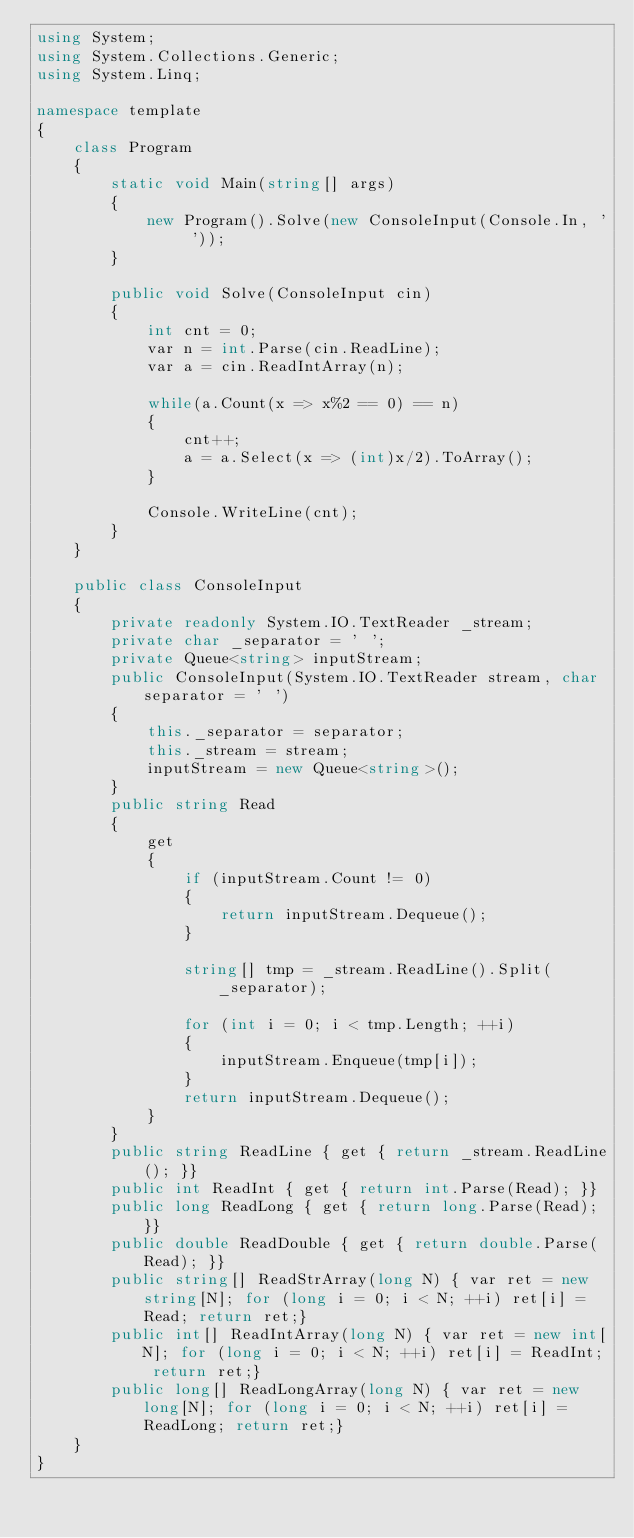<code> <loc_0><loc_0><loc_500><loc_500><_C#_>using System;
using System.Collections.Generic;
using System.Linq;

namespace template
{
    class Program
    {
        static void Main(string[] args)
        {
            new Program().Solve(new ConsoleInput(Console.In, ' '));
        }

        public void Solve(ConsoleInput cin)
        {
            int cnt = 0;
            var n = int.Parse(cin.ReadLine);
            var a = cin.ReadIntArray(n);

            while(a.Count(x => x%2 == 0) == n)
            {
                cnt++;
                a = a.Select(x => (int)x/2).ToArray();
            }

            Console.WriteLine(cnt);
        }
    }

    public class ConsoleInput
    {
        private readonly System.IO.TextReader _stream;
        private char _separator = ' ';
        private Queue<string> inputStream;
        public ConsoleInput(System.IO.TextReader stream, char separator = ' ')
        {
            this._separator = separator;
            this._stream = stream;
            inputStream = new Queue<string>();
        }
        public string Read
        {
            get
            {
                if (inputStream.Count != 0) 
                {
                    return inputStream.Dequeue();
                }

                string[] tmp = _stream.ReadLine().Split(_separator);
                
                for (int i = 0; i < tmp.Length; ++i)
                {
                    inputStream.Enqueue(tmp[i]);
                }
                return inputStream.Dequeue();
            }
        }
        public string ReadLine { get { return _stream.ReadLine(); }}
        public int ReadInt { get { return int.Parse(Read); }}
        public long ReadLong { get { return long.Parse(Read); }}
        public double ReadDouble { get { return double.Parse(Read); }}
        public string[] ReadStrArray(long N) { var ret = new string[N]; for (long i = 0; i < N; ++i) ret[i] = Read; return ret;}
        public int[] ReadIntArray(long N) { var ret = new int[N]; for (long i = 0; i < N; ++i) ret[i] = ReadInt; return ret;}
        public long[] ReadLongArray(long N) { var ret = new long[N]; for (long i = 0; i < N; ++i) ret[i] = ReadLong; return ret;}
    }
}
</code> 